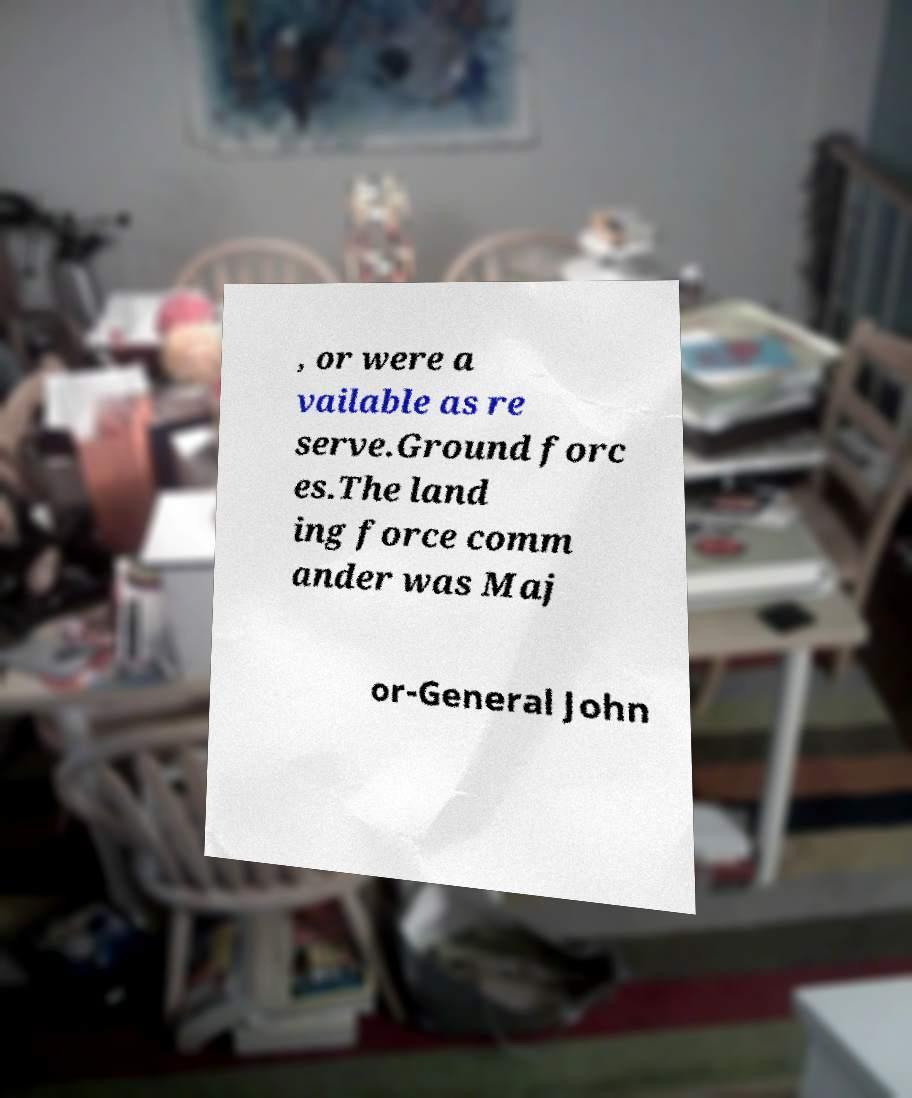Could you extract and type out the text from this image? , or were a vailable as re serve.Ground forc es.The land ing force comm ander was Maj or-General John 